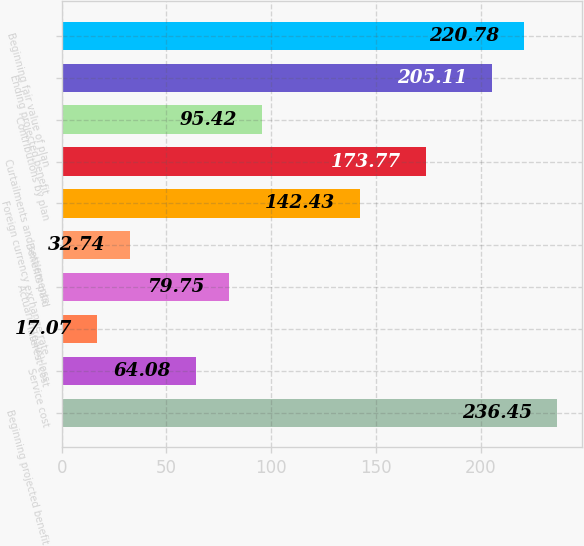Convert chart to OTSL. <chart><loc_0><loc_0><loc_500><loc_500><bar_chart><fcel>Beginning projected benefit<fcel>Service cost<fcel>Interest cost<fcel>Actuarial (gain) loss<fcel>Benefits paid<fcel>Foreign currency exchange rate<fcel>Curtailments and settlements<fcel>Contributions by plan<fcel>Ending projected benefit<fcel>Beginning fair value of plan<nl><fcel>236.45<fcel>64.08<fcel>17.07<fcel>79.75<fcel>32.74<fcel>142.43<fcel>173.77<fcel>95.42<fcel>205.11<fcel>220.78<nl></chart> 